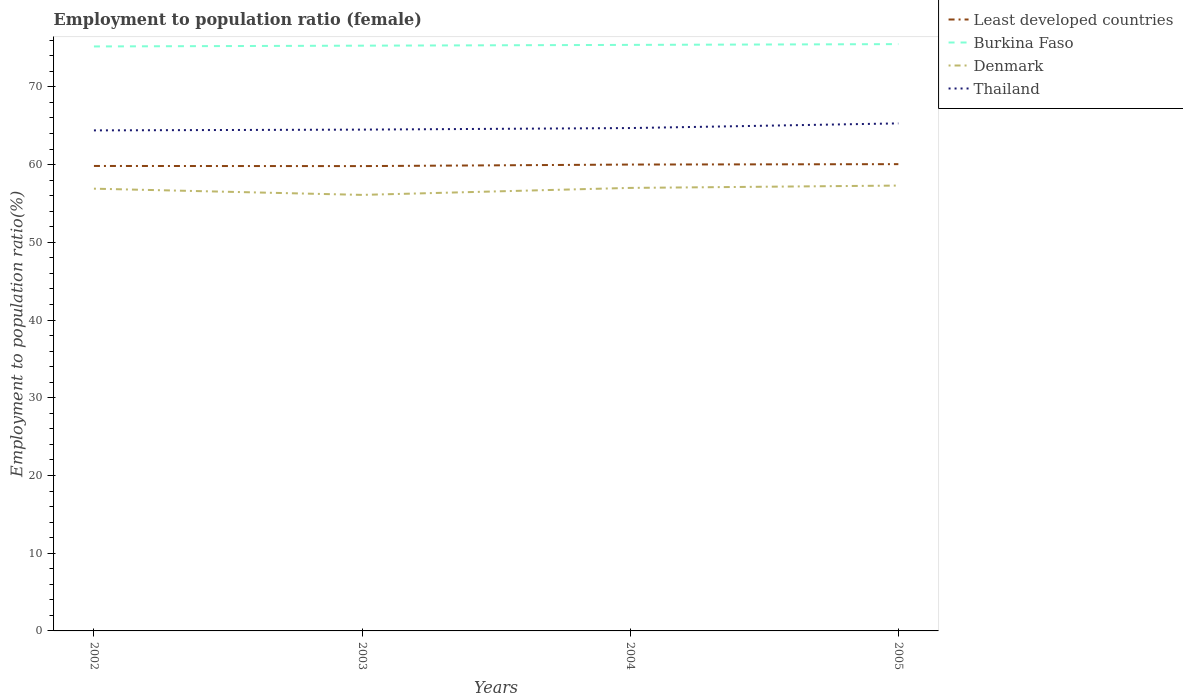How many different coloured lines are there?
Offer a terse response. 4. Does the line corresponding to Least developed countries intersect with the line corresponding to Thailand?
Ensure brevity in your answer.  No. Across all years, what is the maximum employment to population ratio in Burkina Faso?
Your response must be concise. 75.2. What is the total employment to population ratio in Burkina Faso in the graph?
Provide a short and direct response. -0.3. What is the difference between the highest and the second highest employment to population ratio in Burkina Faso?
Your answer should be compact. 0.3. How many lines are there?
Give a very brief answer. 4. What is the difference between two consecutive major ticks on the Y-axis?
Give a very brief answer. 10. Does the graph contain any zero values?
Your response must be concise. No. Does the graph contain grids?
Your response must be concise. No. How many legend labels are there?
Offer a terse response. 4. How are the legend labels stacked?
Offer a terse response. Vertical. What is the title of the graph?
Make the answer very short. Employment to population ratio (female). What is the label or title of the Y-axis?
Offer a very short reply. Employment to population ratio(%). What is the Employment to population ratio(%) in Least developed countries in 2002?
Provide a succinct answer. 59.82. What is the Employment to population ratio(%) of Burkina Faso in 2002?
Keep it short and to the point. 75.2. What is the Employment to population ratio(%) in Denmark in 2002?
Provide a short and direct response. 56.9. What is the Employment to population ratio(%) in Thailand in 2002?
Keep it short and to the point. 64.4. What is the Employment to population ratio(%) in Least developed countries in 2003?
Your answer should be very brief. 59.81. What is the Employment to population ratio(%) of Burkina Faso in 2003?
Ensure brevity in your answer.  75.3. What is the Employment to population ratio(%) of Denmark in 2003?
Offer a very short reply. 56.1. What is the Employment to population ratio(%) of Thailand in 2003?
Make the answer very short. 64.5. What is the Employment to population ratio(%) of Least developed countries in 2004?
Ensure brevity in your answer.  60. What is the Employment to population ratio(%) of Burkina Faso in 2004?
Provide a succinct answer. 75.4. What is the Employment to population ratio(%) in Thailand in 2004?
Your answer should be very brief. 64.7. What is the Employment to population ratio(%) in Least developed countries in 2005?
Make the answer very short. 60.06. What is the Employment to population ratio(%) in Burkina Faso in 2005?
Keep it short and to the point. 75.5. What is the Employment to population ratio(%) of Denmark in 2005?
Provide a short and direct response. 57.3. What is the Employment to population ratio(%) in Thailand in 2005?
Make the answer very short. 65.3. Across all years, what is the maximum Employment to population ratio(%) of Least developed countries?
Your answer should be very brief. 60.06. Across all years, what is the maximum Employment to population ratio(%) of Burkina Faso?
Offer a terse response. 75.5. Across all years, what is the maximum Employment to population ratio(%) in Denmark?
Make the answer very short. 57.3. Across all years, what is the maximum Employment to population ratio(%) in Thailand?
Keep it short and to the point. 65.3. Across all years, what is the minimum Employment to population ratio(%) of Least developed countries?
Keep it short and to the point. 59.81. Across all years, what is the minimum Employment to population ratio(%) in Burkina Faso?
Offer a very short reply. 75.2. Across all years, what is the minimum Employment to population ratio(%) of Denmark?
Your response must be concise. 56.1. Across all years, what is the minimum Employment to population ratio(%) of Thailand?
Your answer should be very brief. 64.4. What is the total Employment to population ratio(%) of Least developed countries in the graph?
Keep it short and to the point. 239.69. What is the total Employment to population ratio(%) in Burkina Faso in the graph?
Offer a terse response. 301.4. What is the total Employment to population ratio(%) in Denmark in the graph?
Your answer should be compact. 227.3. What is the total Employment to population ratio(%) of Thailand in the graph?
Ensure brevity in your answer.  258.9. What is the difference between the Employment to population ratio(%) of Least developed countries in 2002 and that in 2003?
Offer a terse response. 0.02. What is the difference between the Employment to population ratio(%) in Denmark in 2002 and that in 2003?
Offer a terse response. 0.8. What is the difference between the Employment to population ratio(%) of Least developed countries in 2002 and that in 2004?
Keep it short and to the point. -0.18. What is the difference between the Employment to population ratio(%) in Burkina Faso in 2002 and that in 2004?
Keep it short and to the point. -0.2. What is the difference between the Employment to population ratio(%) of Thailand in 2002 and that in 2004?
Keep it short and to the point. -0.3. What is the difference between the Employment to population ratio(%) of Least developed countries in 2002 and that in 2005?
Provide a short and direct response. -0.23. What is the difference between the Employment to population ratio(%) in Denmark in 2002 and that in 2005?
Your answer should be very brief. -0.4. What is the difference between the Employment to population ratio(%) of Thailand in 2002 and that in 2005?
Offer a terse response. -0.9. What is the difference between the Employment to population ratio(%) in Least developed countries in 2003 and that in 2004?
Provide a succinct answer. -0.2. What is the difference between the Employment to population ratio(%) of Thailand in 2003 and that in 2004?
Make the answer very short. -0.2. What is the difference between the Employment to population ratio(%) of Least developed countries in 2003 and that in 2005?
Offer a very short reply. -0.25. What is the difference between the Employment to population ratio(%) in Burkina Faso in 2003 and that in 2005?
Give a very brief answer. -0.2. What is the difference between the Employment to population ratio(%) in Thailand in 2003 and that in 2005?
Give a very brief answer. -0.8. What is the difference between the Employment to population ratio(%) in Least developed countries in 2004 and that in 2005?
Offer a terse response. -0.05. What is the difference between the Employment to population ratio(%) of Burkina Faso in 2004 and that in 2005?
Keep it short and to the point. -0.1. What is the difference between the Employment to population ratio(%) in Least developed countries in 2002 and the Employment to population ratio(%) in Burkina Faso in 2003?
Make the answer very short. -15.48. What is the difference between the Employment to population ratio(%) of Least developed countries in 2002 and the Employment to population ratio(%) of Denmark in 2003?
Offer a terse response. 3.72. What is the difference between the Employment to population ratio(%) of Least developed countries in 2002 and the Employment to population ratio(%) of Thailand in 2003?
Offer a very short reply. -4.68. What is the difference between the Employment to population ratio(%) in Burkina Faso in 2002 and the Employment to population ratio(%) in Denmark in 2003?
Your response must be concise. 19.1. What is the difference between the Employment to population ratio(%) of Denmark in 2002 and the Employment to population ratio(%) of Thailand in 2003?
Ensure brevity in your answer.  -7.6. What is the difference between the Employment to population ratio(%) in Least developed countries in 2002 and the Employment to population ratio(%) in Burkina Faso in 2004?
Offer a very short reply. -15.58. What is the difference between the Employment to population ratio(%) in Least developed countries in 2002 and the Employment to population ratio(%) in Denmark in 2004?
Provide a short and direct response. 2.82. What is the difference between the Employment to population ratio(%) in Least developed countries in 2002 and the Employment to population ratio(%) in Thailand in 2004?
Provide a short and direct response. -4.88. What is the difference between the Employment to population ratio(%) in Denmark in 2002 and the Employment to population ratio(%) in Thailand in 2004?
Ensure brevity in your answer.  -7.8. What is the difference between the Employment to population ratio(%) of Least developed countries in 2002 and the Employment to population ratio(%) of Burkina Faso in 2005?
Your response must be concise. -15.68. What is the difference between the Employment to population ratio(%) of Least developed countries in 2002 and the Employment to population ratio(%) of Denmark in 2005?
Your response must be concise. 2.52. What is the difference between the Employment to population ratio(%) in Least developed countries in 2002 and the Employment to population ratio(%) in Thailand in 2005?
Ensure brevity in your answer.  -5.48. What is the difference between the Employment to population ratio(%) in Burkina Faso in 2002 and the Employment to population ratio(%) in Thailand in 2005?
Offer a very short reply. 9.9. What is the difference between the Employment to population ratio(%) of Denmark in 2002 and the Employment to population ratio(%) of Thailand in 2005?
Give a very brief answer. -8.4. What is the difference between the Employment to population ratio(%) of Least developed countries in 2003 and the Employment to population ratio(%) of Burkina Faso in 2004?
Your answer should be compact. -15.59. What is the difference between the Employment to population ratio(%) of Least developed countries in 2003 and the Employment to population ratio(%) of Denmark in 2004?
Your answer should be compact. 2.81. What is the difference between the Employment to population ratio(%) of Least developed countries in 2003 and the Employment to population ratio(%) of Thailand in 2004?
Your answer should be very brief. -4.89. What is the difference between the Employment to population ratio(%) of Burkina Faso in 2003 and the Employment to population ratio(%) of Thailand in 2004?
Ensure brevity in your answer.  10.6. What is the difference between the Employment to population ratio(%) in Denmark in 2003 and the Employment to population ratio(%) in Thailand in 2004?
Provide a succinct answer. -8.6. What is the difference between the Employment to population ratio(%) in Least developed countries in 2003 and the Employment to population ratio(%) in Burkina Faso in 2005?
Your answer should be very brief. -15.69. What is the difference between the Employment to population ratio(%) of Least developed countries in 2003 and the Employment to population ratio(%) of Denmark in 2005?
Offer a terse response. 2.51. What is the difference between the Employment to population ratio(%) in Least developed countries in 2003 and the Employment to population ratio(%) in Thailand in 2005?
Provide a short and direct response. -5.49. What is the difference between the Employment to population ratio(%) in Burkina Faso in 2003 and the Employment to population ratio(%) in Thailand in 2005?
Give a very brief answer. 10. What is the difference between the Employment to population ratio(%) in Denmark in 2003 and the Employment to population ratio(%) in Thailand in 2005?
Ensure brevity in your answer.  -9.2. What is the difference between the Employment to population ratio(%) in Least developed countries in 2004 and the Employment to population ratio(%) in Burkina Faso in 2005?
Offer a very short reply. -15.5. What is the difference between the Employment to population ratio(%) in Least developed countries in 2004 and the Employment to population ratio(%) in Denmark in 2005?
Offer a terse response. 2.7. What is the difference between the Employment to population ratio(%) of Least developed countries in 2004 and the Employment to population ratio(%) of Thailand in 2005?
Give a very brief answer. -5.3. What is the difference between the Employment to population ratio(%) of Burkina Faso in 2004 and the Employment to population ratio(%) of Thailand in 2005?
Make the answer very short. 10.1. What is the difference between the Employment to population ratio(%) of Denmark in 2004 and the Employment to population ratio(%) of Thailand in 2005?
Give a very brief answer. -8.3. What is the average Employment to population ratio(%) in Least developed countries per year?
Offer a terse response. 59.92. What is the average Employment to population ratio(%) in Burkina Faso per year?
Provide a succinct answer. 75.35. What is the average Employment to population ratio(%) of Denmark per year?
Provide a short and direct response. 56.83. What is the average Employment to population ratio(%) of Thailand per year?
Keep it short and to the point. 64.72. In the year 2002, what is the difference between the Employment to population ratio(%) of Least developed countries and Employment to population ratio(%) of Burkina Faso?
Your answer should be compact. -15.38. In the year 2002, what is the difference between the Employment to population ratio(%) of Least developed countries and Employment to population ratio(%) of Denmark?
Offer a terse response. 2.92. In the year 2002, what is the difference between the Employment to population ratio(%) in Least developed countries and Employment to population ratio(%) in Thailand?
Make the answer very short. -4.58. In the year 2003, what is the difference between the Employment to population ratio(%) of Least developed countries and Employment to population ratio(%) of Burkina Faso?
Keep it short and to the point. -15.49. In the year 2003, what is the difference between the Employment to population ratio(%) in Least developed countries and Employment to population ratio(%) in Denmark?
Keep it short and to the point. 3.71. In the year 2003, what is the difference between the Employment to population ratio(%) in Least developed countries and Employment to population ratio(%) in Thailand?
Keep it short and to the point. -4.69. In the year 2003, what is the difference between the Employment to population ratio(%) of Burkina Faso and Employment to population ratio(%) of Denmark?
Offer a very short reply. 19.2. In the year 2003, what is the difference between the Employment to population ratio(%) in Denmark and Employment to population ratio(%) in Thailand?
Ensure brevity in your answer.  -8.4. In the year 2004, what is the difference between the Employment to population ratio(%) in Least developed countries and Employment to population ratio(%) in Burkina Faso?
Offer a terse response. -15.4. In the year 2004, what is the difference between the Employment to population ratio(%) in Least developed countries and Employment to population ratio(%) in Denmark?
Your answer should be compact. 3. In the year 2004, what is the difference between the Employment to population ratio(%) of Least developed countries and Employment to population ratio(%) of Thailand?
Provide a short and direct response. -4.7. In the year 2004, what is the difference between the Employment to population ratio(%) of Burkina Faso and Employment to population ratio(%) of Thailand?
Your response must be concise. 10.7. In the year 2004, what is the difference between the Employment to population ratio(%) in Denmark and Employment to population ratio(%) in Thailand?
Keep it short and to the point. -7.7. In the year 2005, what is the difference between the Employment to population ratio(%) in Least developed countries and Employment to population ratio(%) in Burkina Faso?
Offer a terse response. -15.44. In the year 2005, what is the difference between the Employment to population ratio(%) of Least developed countries and Employment to population ratio(%) of Denmark?
Give a very brief answer. 2.76. In the year 2005, what is the difference between the Employment to population ratio(%) in Least developed countries and Employment to population ratio(%) in Thailand?
Your answer should be compact. -5.24. In the year 2005, what is the difference between the Employment to population ratio(%) of Burkina Faso and Employment to population ratio(%) of Denmark?
Offer a terse response. 18.2. In the year 2005, what is the difference between the Employment to population ratio(%) in Denmark and Employment to population ratio(%) in Thailand?
Keep it short and to the point. -8. What is the ratio of the Employment to population ratio(%) of Burkina Faso in 2002 to that in 2003?
Offer a terse response. 1. What is the ratio of the Employment to population ratio(%) in Denmark in 2002 to that in 2003?
Give a very brief answer. 1.01. What is the ratio of the Employment to population ratio(%) of Thailand in 2002 to that in 2003?
Give a very brief answer. 1. What is the ratio of the Employment to population ratio(%) of Denmark in 2002 to that in 2004?
Keep it short and to the point. 1. What is the ratio of the Employment to population ratio(%) of Burkina Faso in 2002 to that in 2005?
Your answer should be compact. 1. What is the ratio of the Employment to population ratio(%) of Denmark in 2002 to that in 2005?
Provide a short and direct response. 0.99. What is the ratio of the Employment to population ratio(%) in Thailand in 2002 to that in 2005?
Your answer should be very brief. 0.99. What is the ratio of the Employment to population ratio(%) of Denmark in 2003 to that in 2004?
Offer a very short reply. 0.98. What is the ratio of the Employment to population ratio(%) in Thailand in 2003 to that in 2004?
Your answer should be very brief. 1. What is the ratio of the Employment to population ratio(%) in Denmark in 2003 to that in 2005?
Provide a succinct answer. 0.98. What is the ratio of the Employment to population ratio(%) in Least developed countries in 2004 to that in 2005?
Provide a short and direct response. 1. What is the difference between the highest and the second highest Employment to population ratio(%) in Least developed countries?
Make the answer very short. 0.05. What is the difference between the highest and the second highest Employment to population ratio(%) in Burkina Faso?
Make the answer very short. 0.1. What is the difference between the highest and the lowest Employment to population ratio(%) of Least developed countries?
Provide a short and direct response. 0.25. What is the difference between the highest and the lowest Employment to population ratio(%) of Burkina Faso?
Ensure brevity in your answer.  0.3. 